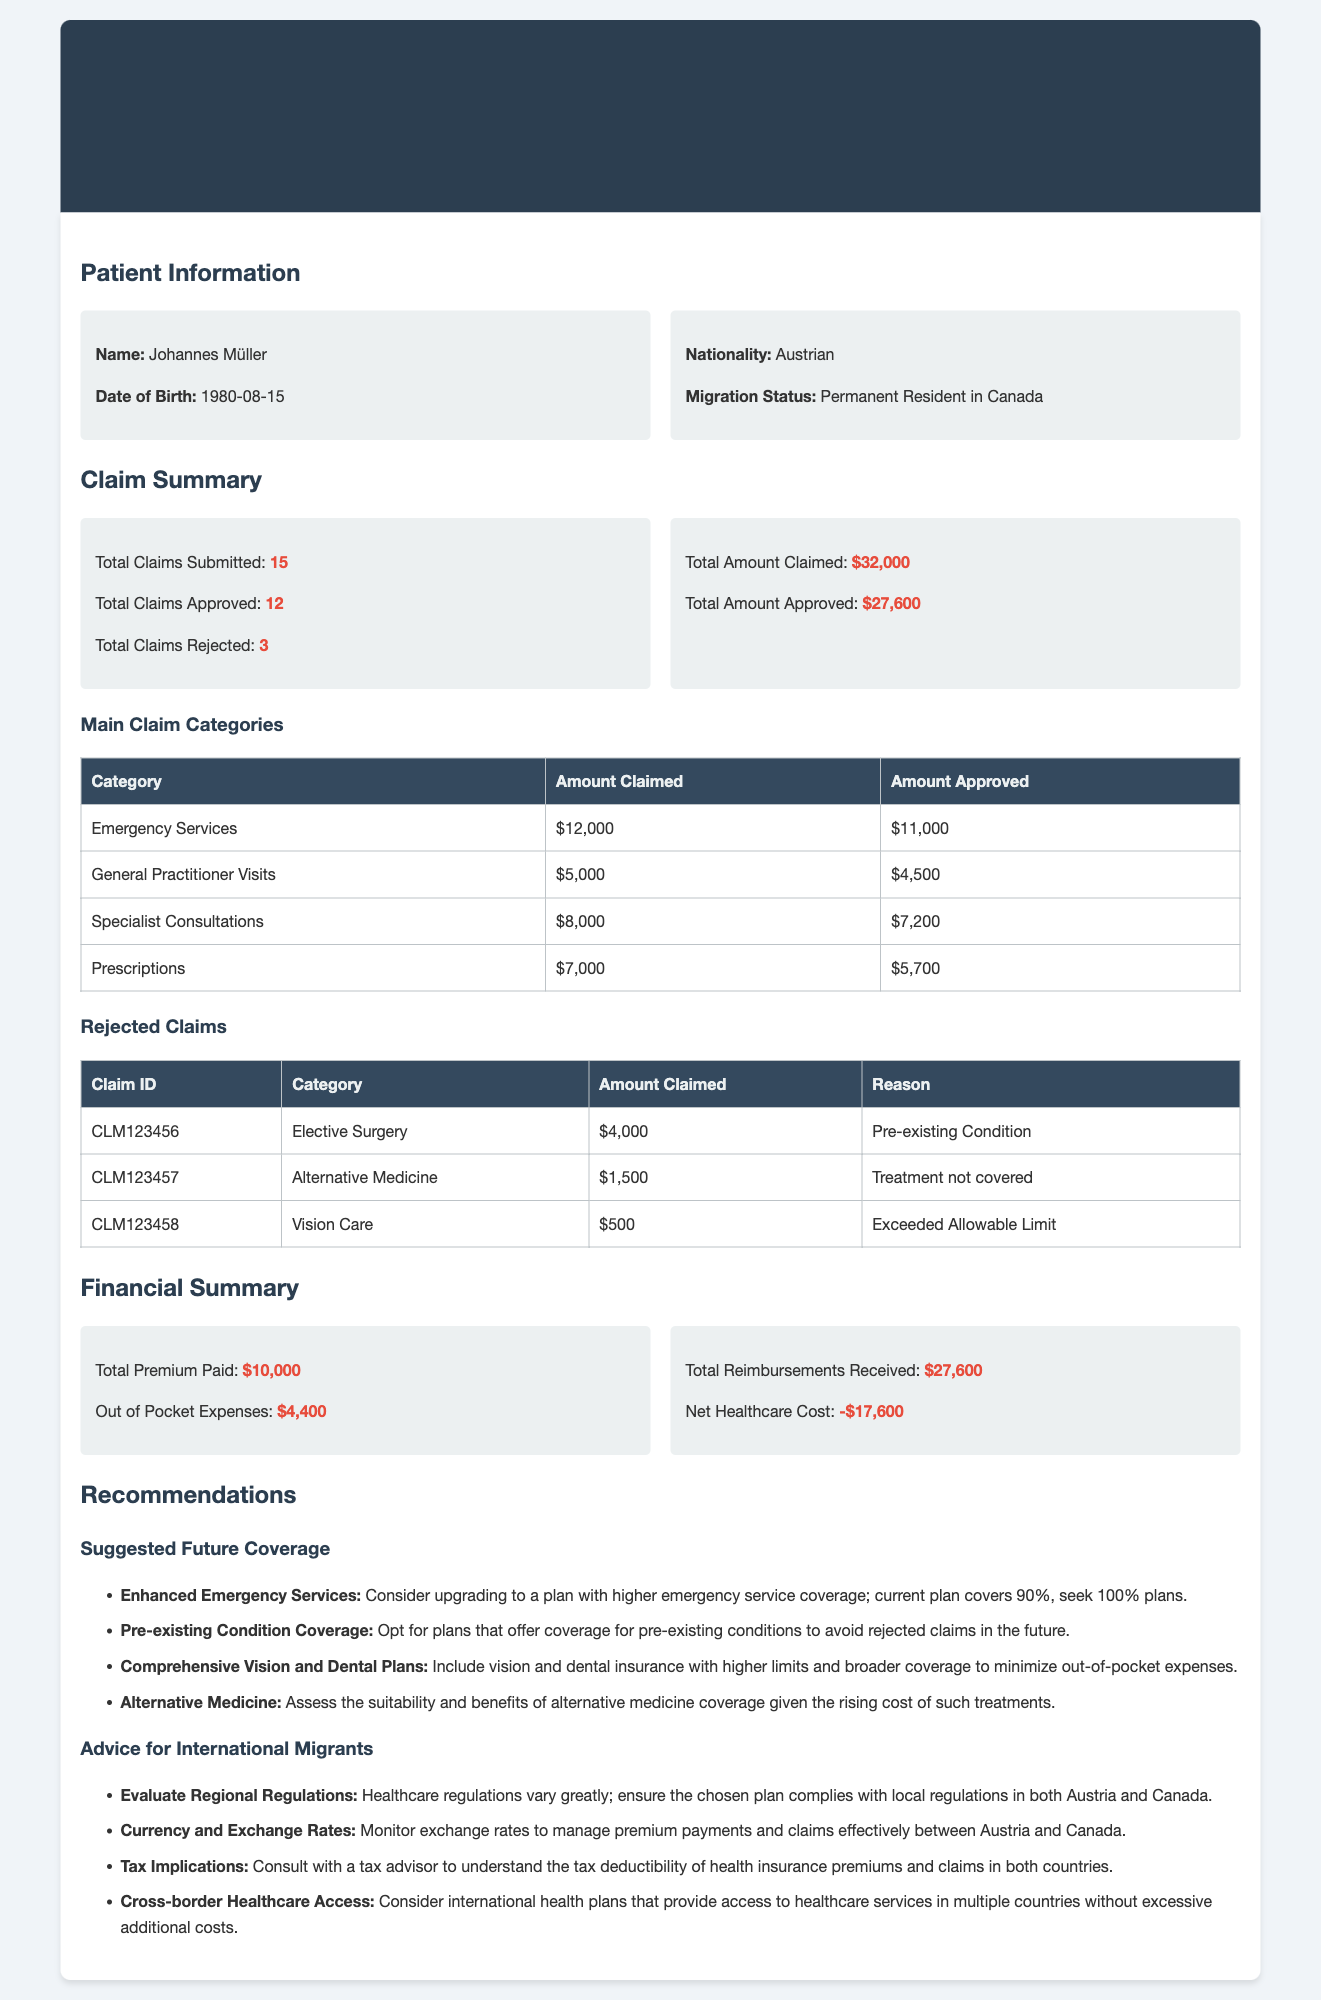What is the date of birth of the patient? The date of birth of Johannes Müller is mentioned in the patient information section of the document.
Answer: 1980-08-15 How many total claims were submitted? The document states the total claims submitted, which can be found in the claim summary section.
Answer: 15 What is the total amount claimed? The total amount claimed is listed in the claim summary section of the document.
Answer: $32,000 Which category had the highest amount claimed? By reviewing the main claim categories table, we find the category with the highest amount claimed.
Answer: Emergency Services What was the reason for rejecting claims? The reasons for rejected claims are detailed in the rejected claims table.
Answer: Pre-existing Condition What is the total premium paid? The total premium paid is displayed in the financial summary section of the document.
Answer: $10,000 How much was the net healthcare cost? The net healthcare cost is calculated in the financial summary from the total amounts approved and paid.
Answer: -$17,600 What does the recommendation suggest about emergency services? The recommendations section includes advice regarding emergency services coverage.
Answer: Consider upgrading to a plan with higher emergency service coverage What is a suggestion for international migrants? The document includes several suggestions for international migrants, focusing on critical areas they should evaluate.
Answer: Evaluate Regional Regulations 